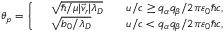<formula> <loc_0><loc_0><loc_500><loc_500>{ \theta } _ { p } = \left \{ \begin{array} { r l r } & { \sqrt { \hbar { / } \mu | \vec { v } _ { r } | \lambda _ { D } } \quad } & { u / c \geq q _ { \alpha } q _ { \beta } / 2 \pi \varepsilon _ { 0 } \hbar { c } , } \\ & { \sqrt { b _ { 0 } / \lambda _ { D } } \quad } & { u / c < q _ { \alpha } q _ { \beta } / 2 \pi \varepsilon _ { 0 } \hbar { c } , } \end{array}</formula> 